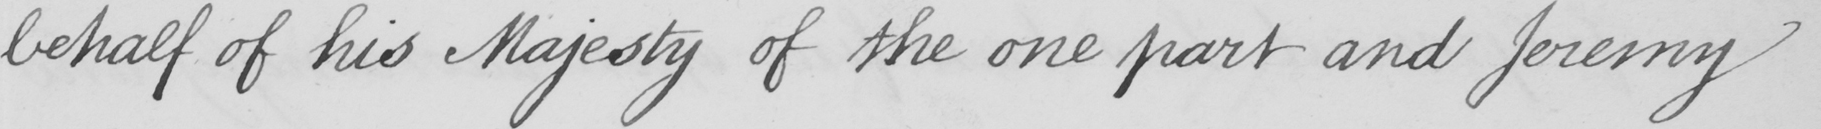What does this handwritten line say? behalf of his Majesty of the one part and Jeremy 